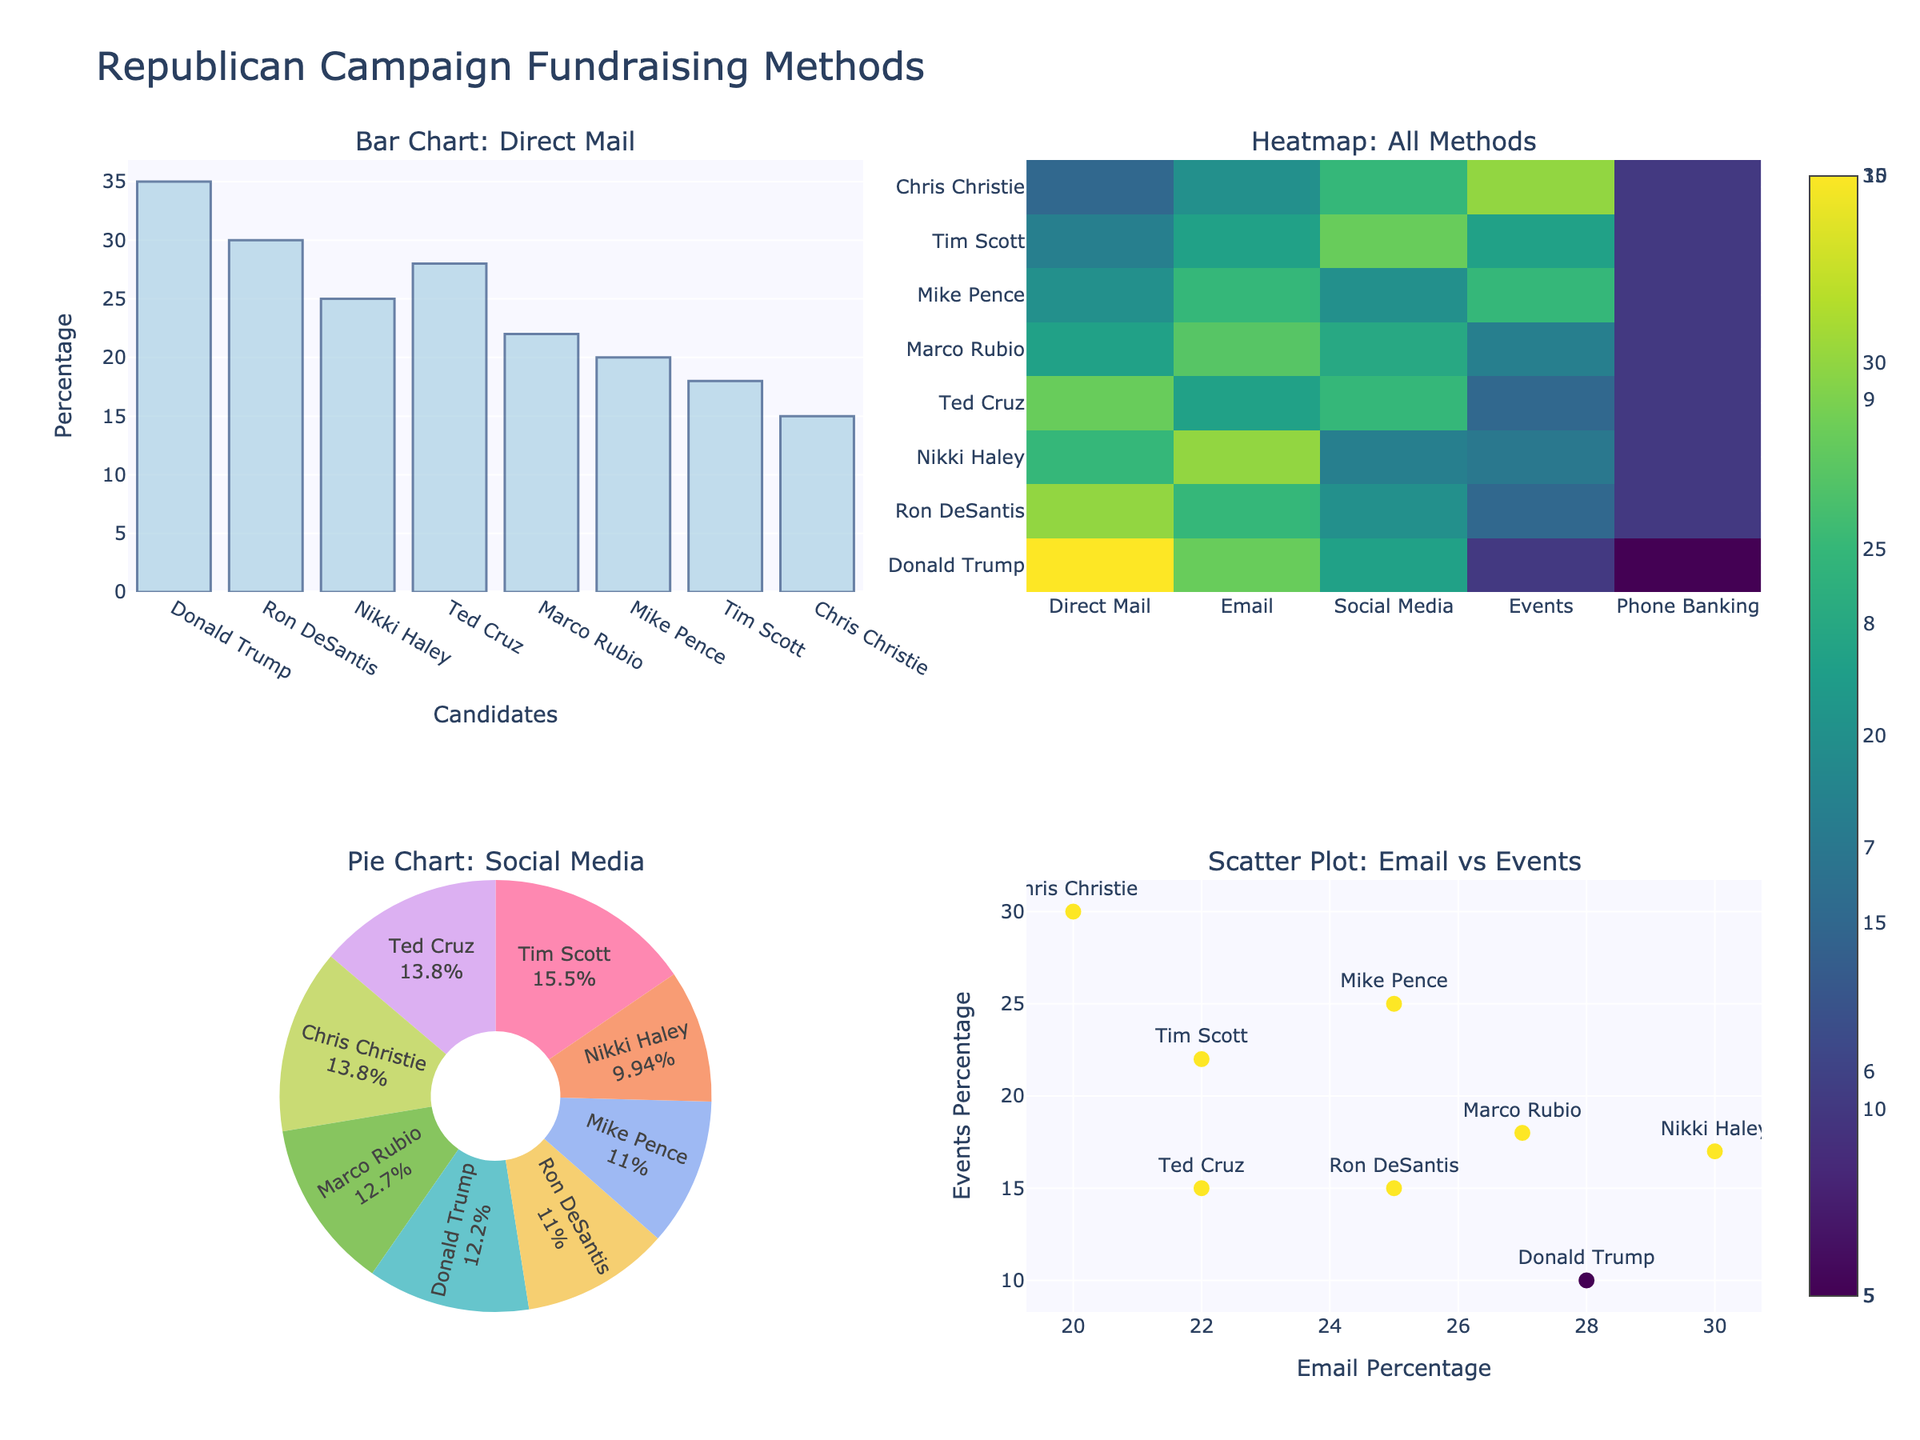Which field has the highest tuition cost for top-ranked universities? Look at the bar heights in the top-ranked category across all fields. The highest bar is for Medicine.
Answer: Medicine What is the tuition cost difference between mid-ranked and lower-ranked Law schools? Locate the bars for Law in mid-ranked and lower-ranked subplots. Mid-ranked Law schools have a tuition cost of $48,000, while lower-ranked have $35,000. The difference is $48,000 - $35,000.
Answer: $13,000 Compare the tuition costs for Business (MBA) in top-ranked and mid-ranked categories. Which one is higher? Observe the bars for Business (MBA) in top-ranked and mid-ranked subplots. The top-ranked bar is higher than the mid-ranked bar.
Answer: Top-ranked For which field is the tuition cost almost the same across all three university rankings? Compare the heights of the bars for each field. Education shows bars that are relatively close in height for top, mid, and lower-ranked universities.
Answer: Education What is the total tuition cost for Engineering in top-ranked, mid-ranked, and lower-ranked universities combined? Sum the costs for Engineering: $50,000 (top-ranked) + $40,000 (mid-ranked) + $28,000 (lower-ranked) = $118,000
Answer: $118,000 Which field has the lowest tuition cost among top-ranked universities? Look for the shortest bar in the top-ranked category across all fields. The shortest bar is for Education.
Answer: Education How does the tuition cost for lower-ranked Psychology compare to lower-ranked Public Policy? Observe the lower-ranked bars for both fields. Psychology is at $24,000, and Public Policy is at $26,000. Psychology is lower.
Answer: Psychology is lower What is the average tuition cost for mid-ranked universities across all fields? Sum the mid-ranked tuition costs for all fields and divide by the number of fields: (45000 + 35000 + 40000 + 48000 + 55000 + 28000 + 32000 + 34000) / 8 = $38,375
Answer: $38,375 Which fields have a lower tuition cost for mid-ranked universities compared to top-ranked ones by an amount greater than $15,000? Compare the bars for each field. Only Medicine fits as it drops $15,000 from $70,000 to $55,000.
Answer: Medicine 